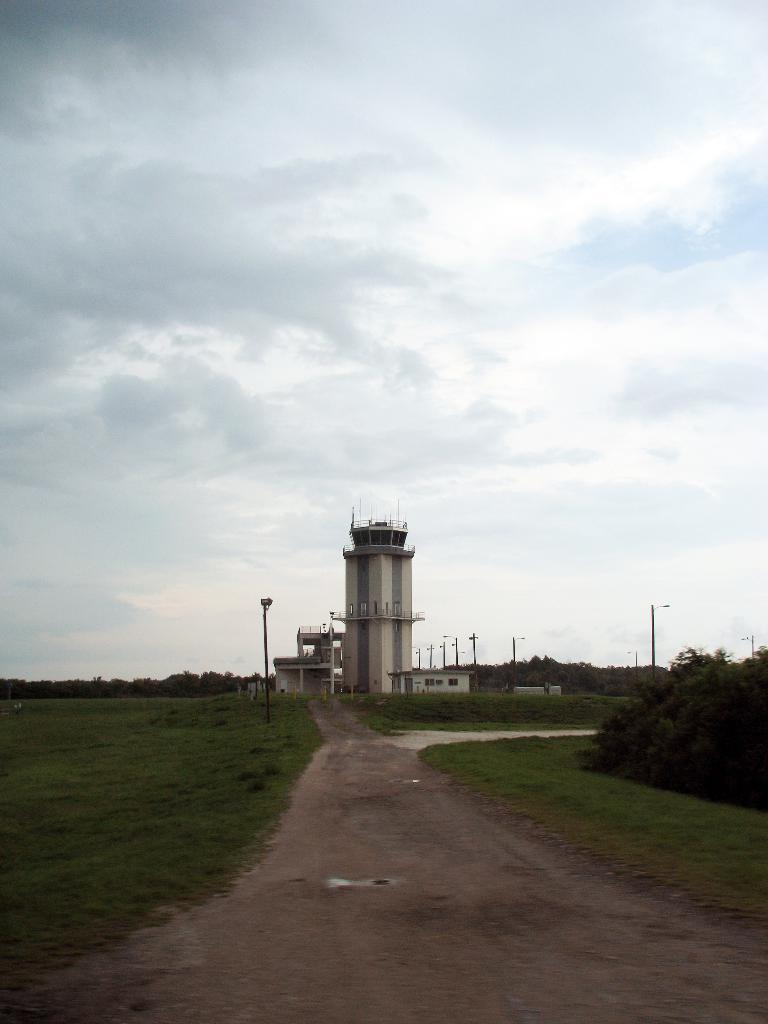What type of structure is visible in the image? There is a building in the image. What other objects can be seen in the image? Poles, grass, a pathway, street poles, a group of trees, and the sky are visible in the image. Can you describe the pathway in the image? There is a pathway in the image. What is the condition of the sky in the image? The sky appears cloudy in the image. Can you tell me how many visitors are waiting outside the prison in the image? There is no prison or visitors present in the image. What is the father doing in the image? There is no father or activity involving a father present in the image. 